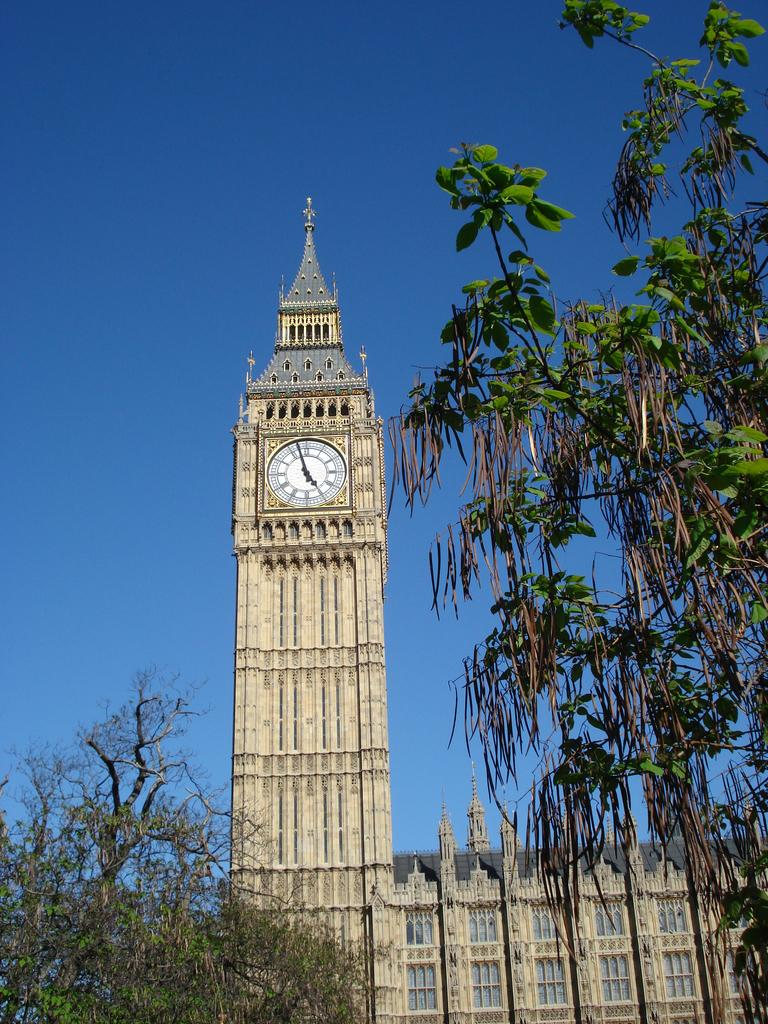What type of structure is present in the image? There is a building in the image. What object can be seen on the building? There is a clock in the image. What type of vegetation is visible in the image? There are trees in the image. What is visible at the top of the image? The sky is visible at the top of the image. Can you tell me how many strings are attached to the snails in the image? There are no snails or strings present in the image. Who is the partner of the person in the image? There is no person in the image, so there is no partner to identify. 